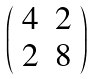<formula> <loc_0><loc_0><loc_500><loc_500>\left ( \begin{array} { c c } 4 & 2 \\ 2 & 8 \end{array} \right )</formula> 